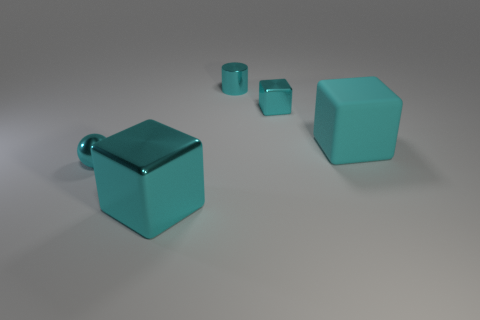How many cyan cubes must be subtracted to get 1 cyan cubes? 2 Subtract all big cyan blocks. How many blocks are left? 1 Subtract all balls. How many objects are left? 4 Subtract all brown blocks. Subtract all red spheres. How many blocks are left? 3 Subtract all large cubes. Subtract all balls. How many objects are left? 2 Add 5 big cyan objects. How many big cyan objects are left? 7 Add 1 tiny brown matte spheres. How many tiny brown matte spheres exist? 1 Add 3 big cyan metallic blocks. How many objects exist? 8 Subtract 0 gray cylinders. How many objects are left? 5 Subtract 1 blocks. How many blocks are left? 2 